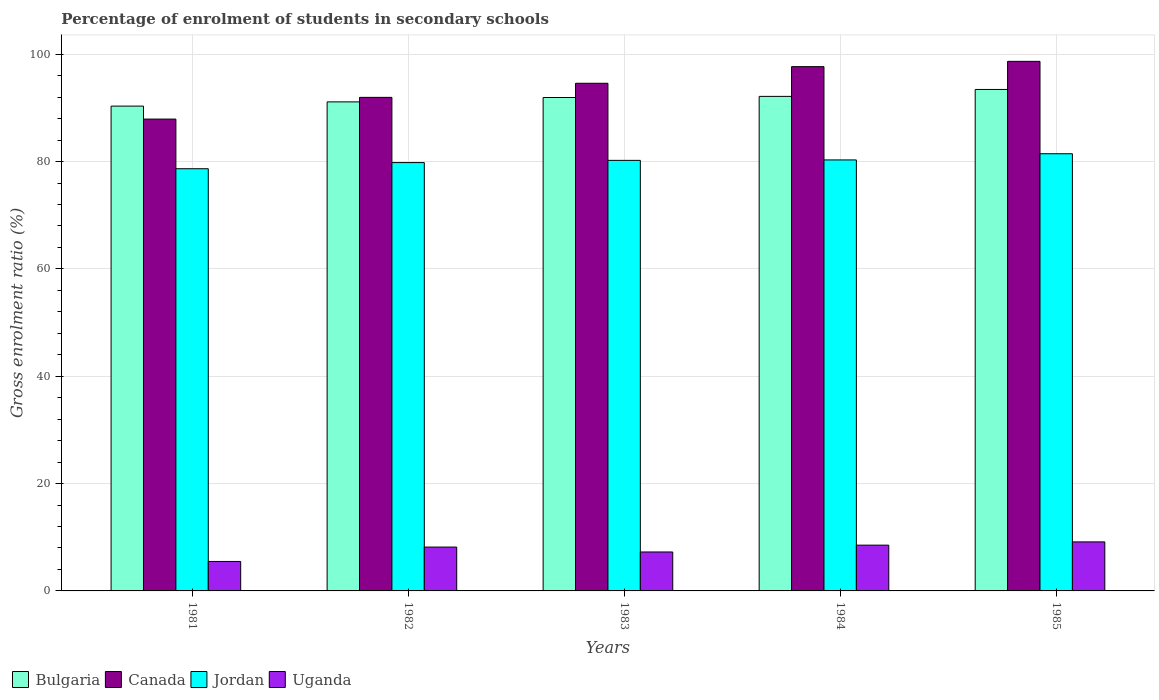How many different coloured bars are there?
Give a very brief answer. 4. How many groups of bars are there?
Make the answer very short. 5. Are the number of bars per tick equal to the number of legend labels?
Provide a succinct answer. Yes. How many bars are there on the 5th tick from the left?
Your answer should be very brief. 4. In how many cases, is the number of bars for a given year not equal to the number of legend labels?
Make the answer very short. 0. What is the percentage of students enrolled in secondary schools in Canada in 1983?
Your answer should be very brief. 94.59. Across all years, what is the maximum percentage of students enrolled in secondary schools in Jordan?
Offer a terse response. 81.46. Across all years, what is the minimum percentage of students enrolled in secondary schools in Bulgaria?
Ensure brevity in your answer.  90.34. What is the total percentage of students enrolled in secondary schools in Jordan in the graph?
Offer a terse response. 400.48. What is the difference between the percentage of students enrolled in secondary schools in Canada in 1981 and that in 1983?
Your answer should be very brief. -6.67. What is the difference between the percentage of students enrolled in secondary schools in Uganda in 1983 and the percentage of students enrolled in secondary schools in Bulgaria in 1984?
Make the answer very short. -84.89. What is the average percentage of students enrolled in secondary schools in Jordan per year?
Your response must be concise. 80.1. In the year 1985, what is the difference between the percentage of students enrolled in secondary schools in Jordan and percentage of students enrolled in secondary schools in Canada?
Your response must be concise. -17.21. In how many years, is the percentage of students enrolled in secondary schools in Bulgaria greater than 80 %?
Provide a succinct answer. 5. What is the ratio of the percentage of students enrolled in secondary schools in Jordan in 1981 to that in 1985?
Offer a very short reply. 0.97. Is the difference between the percentage of students enrolled in secondary schools in Jordan in 1981 and 1982 greater than the difference between the percentage of students enrolled in secondary schools in Canada in 1981 and 1982?
Make the answer very short. Yes. What is the difference between the highest and the second highest percentage of students enrolled in secondary schools in Uganda?
Give a very brief answer. 0.61. What is the difference between the highest and the lowest percentage of students enrolled in secondary schools in Jordan?
Keep it short and to the point. 2.79. Is the sum of the percentage of students enrolled in secondary schools in Jordan in 1981 and 1984 greater than the maximum percentage of students enrolled in secondary schools in Canada across all years?
Offer a terse response. Yes. What does the 4th bar from the left in 1984 represents?
Give a very brief answer. Uganda. What does the 1st bar from the right in 1983 represents?
Offer a very short reply. Uganda. Is it the case that in every year, the sum of the percentage of students enrolled in secondary schools in Bulgaria and percentage of students enrolled in secondary schools in Uganda is greater than the percentage of students enrolled in secondary schools in Canada?
Offer a very short reply. Yes. How many bars are there?
Offer a very short reply. 20. Are all the bars in the graph horizontal?
Your answer should be very brief. No. How many years are there in the graph?
Ensure brevity in your answer.  5. Does the graph contain any zero values?
Your answer should be compact. No. Does the graph contain grids?
Your answer should be very brief. Yes. How many legend labels are there?
Ensure brevity in your answer.  4. What is the title of the graph?
Keep it short and to the point. Percentage of enrolment of students in secondary schools. What is the label or title of the Y-axis?
Provide a succinct answer. Gross enrolment ratio (%). What is the Gross enrolment ratio (%) of Bulgaria in 1981?
Your response must be concise. 90.34. What is the Gross enrolment ratio (%) in Canada in 1981?
Keep it short and to the point. 87.92. What is the Gross enrolment ratio (%) of Jordan in 1981?
Your answer should be very brief. 78.67. What is the Gross enrolment ratio (%) in Uganda in 1981?
Keep it short and to the point. 5.49. What is the Gross enrolment ratio (%) in Bulgaria in 1982?
Provide a short and direct response. 91.13. What is the Gross enrolment ratio (%) of Canada in 1982?
Offer a very short reply. 91.96. What is the Gross enrolment ratio (%) of Jordan in 1982?
Offer a very short reply. 79.81. What is the Gross enrolment ratio (%) in Uganda in 1982?
Give a very brief answer. 8.17. What is the Gross enrolment ratio (%) of Bulgaria in 1983?
Your answer should be very brief. 91.94. What is the Gross enrolment ratio (%) in Canada in 1983?
Offer a very short reply. 94.59. What is the Gross enrolment ratio (%) in Jordan in 1983?
Provide a short and direct response. 80.23. What is the Gross enrolment ratio (%) of Uganda in 1983?
Provide a short and direct response. 7.26. What is the Gross enrolment ratio (%) of Bulgaria in 1984?
Ensure brevity in your answer.  92.15. What is the Gross enrolment ratio (%) of Canada in 1984?
Ensure brevity in your answer.  97.69. What is the Gross enrolment ratio (%) of Jordan in 1984?
Your answer should be very brief. 80.31. What is the Gross enrolment ratio (%) in Uganda in 1984?
Your response must be concise. 8.53. What is the Gross enrolment ratio (%) in Bulgaria in 1985?
Provide a short and direct response. 93.44. What is the Gross enrolment ratio (%) of Canada in 1985?
Provide a succinct answer. 98.68. What is the Gross enrolment ratio (%) in Jordan in 1985?
Make the answer very short. 81.46. What is the Gross enrolment ratio (%) of Uganda in 1985?
Provide a succinct answer. 9.13. Across all years, what is the maximum Gross enrolment ratio (%) of Bulgaria?
Make the answer very short. 93.44. Across all years, what is the maximum Gross enrolment ratio (%) in Canada?
Your response must be concise. 98.68. Across all years, what is the maximum Gross enrolment ratio (%) of Jordan?
Ensure brevity in your answer.  81.46. Across all years, what is the maximum Gross enrolment ratio (%) of Uganda?
Keep it short and to the point. 9.13. Across all years, what is the minimum Gross enrolment ratio (%) of Bulgaria?
Your answer should be compact. 90.34. Across all years, what is the minimum Gross enrolment ratio (%) of Canada?
Offer a terse response. 87.92. Across all years, what is the minimum Gross enrolment ratio (%) of Jordan?
Keep it short and to the point. 78.67. Across all years, what is the minimum Gross enrolment ratio (%) in Uganda?
Provide a succinct answer. 5.49. What is the total Gross enrolment ratio (%) in Bulgaria in the graph?
Make the answer very short. 458.99. What is the total Gross enrolment ratio (%) in Canada in the graph?
Ensure brevity in your answer.  470.84. What is the total Gross enrolment ratio (%) in Jordan in the graph?
Keep it short and to the point. 400.48. What is the total Gross enrolment ratio (%) of Uganda in the graph?
Give a very brief answer. 38.58. What is the difference between the Gross enrolment ratio (%) in Bulgaria in 1981 and that in 1982?
Your answer should be very brief. -0.79. What is the difference between the Gross enrolment ratio (%) of Canada in 1981 and that in 1982?
Keep it short and to the point. -4.04. What is the difference between the Gross enrolment ratio (%) of Jordan in 1981 and that in 1982?
Make the answer very short. -1.14. What is the difference between the Gross enrolment ratio (%) in Uganda in 1981 and that in 1982?
Ensure brevity in your answer.  -2.68. What is the difference between the Gross enrolment ratio (%) in Bulgaria in 1981 and that in 1983?
Give a very brief answer. -1.6. What is the difference between the Gross enrolment ratio (%) in Canada in 1981 and that in 1983?
Keep it short and to the point. -6.67. What is the difference between the Gross enrolment ratio (%) in Jordan in 1981 and that in 1983?
Provide a succinct answer. -1.56. What is the difference between the Gross enrolment ratio (%) in Uganda in 1981 and that in 1983?
Make the answer very short. -1.77. What is the difference between the Gross enrolment ratio (%) in Bulgaria in 1981 and that in 1984?
Your answer should be compact. -1.81. What is the difference between the Gross enrolment ratio (%) in Canada in 1981 and that in 1984?
Offer a very short reply. -9.77. What is the difference between the Gross enrolment ratio (%) in Jordan in 1981 and that in 1984?
Provide a short and direct response. -1.64. What is the difference between the Gross enrolment ratio (%) of Uganda in 1981 and that in 1984?
Provide a succinct answer. -3.04. What is the difference between the Gross enrolment ratio (%) in Bulgaria in 1981 and that in 1985?
Offer a very short reply. -3.1. What is the difference between the Gross enrolment ratio (%) in Canada in 1981 and that in 1985?
Make the answer very short. -10.76. What is the difference between the Gross enrolment ratio (%) of Jordan in 1981 and that in 1985?
Offer a very short reply. -2.79. What is the difference between the Gross enrolment ratio (%) in Uganda in 1981 and that in 1985?
Make the answer very short. -3.64. What is the difference between the Gross enrolment ratio (%) of Bulgaria in 1982 and that in 1983?
Your answer should be very brief. -0.82. What is the difference between the Gross enrolment ratio (%) of Canada in 1982 and that in 1983?
Provide a short and direct response. -2.63. What is the difference between the Gross enrolment ratio (%) in Jordan in 1982 and that in 1983?
Your answer should be very brief. -0.41. What is the difference between the Gross enrolment ratio (%) in Uganda in 1982 and that in 1983?
Provide a short and direct response. 0.91. What is the difference between the Gross enrolment ratio (%) of Bulgaria in 1982 and that in 1984?
Keep it short and to the point. -1.02. What is the difference between the Gross enrolment ratio (%) in Canada in 1982 and that in 1984?
Offer a very short reply. -5.73. What is the difference between the Gross enrolment ratio (%) of Jordan in 1982 and that in 1984?
Your response must be concise. -0.5. What is the difference between the Gross enrolment ratio (%) of Uganda in 1982 and that in 1984?
Give a very brief answer. -0.36. What is the difference between the Gross enrolment ratio (%) of Bulgaria in 1982 and that in 1985?
Offer a very short reply. -2.31. What is the difference between the Gross enrolment ratio (%) in Canada in 1982 and that in 1985?
Offer a terse response. -6.71. What is the difference between the Gross enrolment ratio (%) of Jordan in 1982 and that in 1985?
Offer a terse response. -1.65. What is the difference between the Gross enrolment ratio (%) of Uganda in 1982 and that in 1985?
Provide a short and direct response. -0.96. What is the difference between the Gross enrolment ratio (%) in Bulgaria in 1983 and that in 1984?
Provide a short and direct response. -0.21. What is the difference between the Gross enrolment ratio (%) of Canada in 1983 and that in 1984?
Keep it short and to the point. -3.1. What is the difference between the Gross enrolment ratio (%) in Jordan in 1983 and that in 1984?
Offer a terse response. -0.08. What is the difference between the Gross enrolment ratio (%) in Uganda in 1983 and that in 1984?
Provide a succinct answer. -1.27. What is the difference between the Gross enrolment ratio (%) of Bulgaria in 1983 and that in 1985?
Your answer should be very brief. -1.5. What is the difference between the Gross enrolment ratio (%) of Canada in 1983 and that in 1985?
Ensure brevity in your answer.  -4.09. What is the difference between the Gross enrolment ratio (%) in Jordan in 1983 and that in 1985?
Make the answer very short. -1.24. What is the difference between the Gross enrolment ratio (%) in Uganda in 1983 and that in 1985?
Make the answer very short. -1.88. What is the difference between the Gross enrolment ratio (%) of Bulgaria in 1984 and that in 1985?
Give a very brief answer. -1.29. What is the difference between the Gross enrolment ratio (%) of Canada in 1984 and that in 1985?
Provide a succinct answer. -0.99. What is the difference between the Gross enrolment ratio (%) of Jordan in 1984 and that in 1985?
Provide a short and direct response. -1.15. What is the difference between the Gross enrolment ratio (%) in Uganda in 1984 and that in 1985?
Ensure brevity in your answer.  -0.61. What is the difference between the Gross enrolment ratio (%) of Bulgaria in 1981 and the Gross enrolment ratio (%) of Canada in 1982?
Keep it short and to the point. -1.63. What is the difference between the Gross enrolment ratio (%) of Bulgaria in 1981 and the Gross enrolment ratio (%) of Jordan in 1982?
Your response must be concise. 10.53. What is the difference between the Gross enrolment ratio (%) in Bulgaria in 1981 and the Gross enrolment ratio (%) in Uganda in 1982?
Offer a very short reply. 82.17. What is the difference between the Gross enrolment ratio (%) in Canada in 1981 and the Gross enrolment ratio (%) in Jordan in 1982?
Make the answer very short. 8.11. What is the difference between the Gross enrolment ratio (%) of Canada in 1981 and the Gross enrolment ratio (%) of Uganda in 1982?
Ensure brevity in your answer.  79.75. What is the difference between the Gross enrolment ratio (%) in Jordan in 1981 and the Gross enrolment ratio (%) in Uganda in 1982?
Your answer should be compact. 70.5. What is the difference between the Gross enrolment ratio (%) of Bulgaria in 1981 and the Gross enrolment ratio (%) of Canada in 1983?
Your response must be concise. -4.25. What is the difference between the Gross enrolment ratio (%) of Bulgaria in 1981 and the Gross enrolment ratio (%) of Jordan in 1983?
Your response must be concise. 10.11. What is the difference between the Gross enrolment ratio (%) in Bulgaria in 1981 and the Gross enrolment ratio (%) in Uganda in 1983?
Offer a very short reply. 83.08. What is the difference between the Gross enrolment ratio (%) of Canada in 1981 and the Gross enrolment ratio (%) of Jordan in 1983?
Offer a very short reply. 7.69. What is the difference between the Gross enrolment ratio (%) of Canada in 1981 and the Gross enrolment ratio (%) of Uganda in 1983?
Offer a terse response. 80.66. What is the difference between the Gross enrolment ratio (%) of Jordan in 1981 and the Gross enrolment ratio (%) of Uganda in 1983?
Your answer should be compact. 71.41. What is the difference between the Gross enrolment ratio (%) in Bulgaria in 1981 and the Gross enrolment ratio (%) in Canada in 1984?
Give a very brief answer. -7.35. What is the difference between the Gross enrolment ratio (%) of Bulgaria in 1981 and the Gross enrolment ratio (%) of Jordan in 1984?
Keep it short and to the point. 10.03. What is the difference between the Gross enrolment ratio (%) in Bulgaria in 1981 and the Gross enrolment ratio (%) in Uganda in 1984?
Offer a terse response. 81.81. What is the difference between the Gross enrolment ratio (%) of Canada in 1981 and the Gross enrolment ratio (%) of Jordan in 1984?
Your answer should be compact. 7.61. What is the difference between the Gross enrolment ratio (%) in Canada in 1981 and the Gross enrolment ratio (%) in Uganda in 1984?
Provide a succinct answer. 79.39. What is the difference between the Gross enrolment ratio (%) in Jordan in 1981 and the Gross enrolment ratio (%) in Uganda in 1984?
Provide a short and direct response. 70.14. What is the difference between the Gross enrolment ratio (%) in Bulgaria in 1981 and the Gross enrolment ratio (%) in Canada in 1985?
Offer a very short reply. -8.34. What is the difference between the Gross enrolment ratio (%) of Bulgaria in 1981 and the Gross enrolment ratio (%) of Jordan in 1985?
Ensure brevity in your answer.  8.87. What is the difference between the Gross enrolment ratio (%) in Bulgaria in 1981 and the Gross enrolment ratio (%) in Uganda in 1985?
Provide a short and direct response. 81.2. What is the difference between the Gross enrolment ratio (%) of Canada in 1981 and the Gross enrolment ratio (%) of Jordan in 1985?
Provide a short and direct response. 6.46. What is the difference between the Gross enrolment ratio (%) of Canada in 1981 and the Gross enrolment ratio (%) of Uganda in 1985?
Your answer should be very brief. 78.79. What is the difference between the Gross enrolment ratio (%) in Jordan in 1981 and the Gross enrolment ratio (%) in Uganda in 1985?
Keep it short and to the point. 69.53. What is the difference between the Gross enrolment ratio (%) of Bulgaria in 1982 and the Gross enrolment ratio (%) of Canada in 1983?
Give a very brief answer. -3.47. What is the difference between the Gross enrolment ratio (%) of Bulgaria in 1982 and the Gross enrolment ratio (%) of Jordan in 1983?
Offer a terse response. 10.9. What is the difference between the Gross enrolment ratio (%) of Bulgaria in 1982 and the Gross enrolment ratio (%) of Uganda in 1983?
Your answer should be very brief. 83.87. What is the difference between the Gross enrolment ratio (%) in Canada in 1982 and the Gross enrolment ratio (%) in Jordan in 1983?
Your response must be concise. 11.74. What is the difference between the Gross enrolment ratio (%) of Canada in 1982 and the Gross enrolment ratio (%) of Uganda in 1983?
Provide a succinct answer. 84.71. What is the difference between the Gross enrolment ratio (%) in Jordan in 1982 and the Gross enrolment ratio (%) in Uganda in 1983?
Ensure brevity in your answer.  72.55. What is the difference between the Gross enrolment ratio (%) in Bulgaria in 1982 and the Gross enrolment ratio (%) in Canada in 1984?
Keep it short and to the point. -6.56. What is the difference between the Gross enrolment ratio (%) in Bulgaria in 1982 and the Gross enrolment ratio (%) in Jordan in 1984?
Your answer should be compact. 10.82. What is the difference between the Gross enrolment ratio (%) in Bulgaria in 1982 and the Gross enrolment ratio (%) in Uganda in 1984?
Your response must be concise. 82.6. What is the difference between the Gross enrolment ratio (%) in Canada in 1982 and the Gross enrolment ratio (%) in Jordan in 1984?
Your answer should be very brief. 11.66. What is the difference between the Gross enrolment ratio (%) in Canada in 1982 and the Gross enrolment ratio (%) in Uganda in 1984?
Make the answer very short. 83.44. What is the difference between the Gross enrolment ratio (%) in Jordan in 1982 and the Gross enrolment ratio (%) in Uganda in 1984?
Make the answer very short. 71.28. What is the difference between the Gross enrolment ratio (%) of Bulgaria in 1982 and the Gross enrolment ratio (%) of Canada in 1985?
Ensure brevity in your answer.  -7.55. What is the difference between the Gross enrolment ratio (%) in Bulgaria in 1982 and the Gross enrolment ratio (%) in Jordan in 1985?
Offer a very short reply. 9.66. What is the difference between the Gross enrolment ratio (%) in Bulgaria in 1982 and the Gross enrolment ratio (%) in Uganda in 1985?
Make the answer very short. 81.99. What is the difference between the Gross enrolment ratio (%) in Canada in 1982 and the Gross enrolment ratio (%) in Jordan in 1985?
Ensure brevity in your answer.  10.5. What is the difference between the Gross enrolment ratio (%) of Canada in 1982 and the Gross enrolment ratio (%) of Uganda in 1985?
Provide a short and direct response. 82.83. What is the difference between the Gross enrolment ratio (%) of Jordan in 1982 and the Gross enrolment ratio (%) of Uganda in 1985?
Provide a succinct answer. 70.68. What is the difference between the Gross enrolment ratio (%) of Bulgaria in 1983 and the Gross enrolment ratio (%) of Canada in 1984?
Offer a very short reply. -5.75. What is the difference between the Gross enrolment ratio (%) in Bulgaria in 1983 and the Gross enrolment ratio (%) in Jordan in 1984?
Your answer should be compact. 11.63. What is the difference between the Gross enrolment ratio (%) in Bulgaria in 1983 and the Gross enrolment ratio (%) in Uganda in 1984?
Ensure brevity in your answer.  83.41. What is the difference between the Gross enrolment ratio (%) of Canada in 1983 and the Gross enrolment ratio (%) of Jordan in 1984?
Provide a succinct answer. 14.28. What is the difference between the Gross enrolment ratio (%) of Canada in 1983 and the Gross enrolment ratio (%) of Uganda in 1984?
Make the answer very short. 86.06. What is the difference between the Gross enrolment ratio (%) of Jordan in 1983 and the Gross enrolment ratio (%) of Uganda in 1984?
Keep it short and to the point. 71.7. What is the difference between the Gross enrolment ratio (%) in Bulgaria in 1983 and the Gross enrolment ratio (%) in Canada in 1985?
Offer a terse response. -6.74. What is the difference between the Gross enrolment ratio (%) of Bulgaria in 1983 and the Gross enrolment ratio (%) of Jordan in 1985?
Your answer should be compact. 10.48. What is the difference between the Gross enrolment ratio (%) in Bulgaria in 1983 and the Gross enrolment ratio (%) in Uganda in 1985?
Offer a very short reply. 82.81. What is the difference between the Gross enrolment ratio (%) of Canada in 1983 and the Gross enrolment ratio (%) of Jordan in 1985?
Your response must be concise. 13.13. What is the difference between the Gross enrolment ratio (%) of Canada in 1983 and the Gross enrolment ratio (%) of Uganda in 1985?
Offer a very short reply. 85.46. What is the difference between the Gross enrolment ratio (%) of Jordan in 1983 and the Gross enrolment ratio (%) of Uganda in 1985?
Your response must be concise. 71.09. What is the difference between the Gross enrolment ratio (%) of Bulgaria in 1984 and the Gross enrolment ratio (%) of Canada in 1985?
Ensure brevity in your answer.  -6.53. What is the difference between the Gross enrolment ratio (%) in Bulgaria in 1984 and the Gross enrolment ratio (%) in Jordan in 1985?
Ensure brevity in your answer.  10.69. What is the difference between the Gross enrolment ratio (%) of Bulgaria in 1984 and the Gross enrolment ratio (%) of Uganda in 1985?
Give a very brief answer. 83.01. What is the difference between the Gross enrolment ratio (%) in Canada in 1984 and the Gross enrolment ratio (%) in Jordan in 1985?
Keep it short and to the point. 16.23. What is the difference between the Gross enrolment ratio (%) of Canada in 1984 and the Gross enrolment ratio (%) of Uganda in 1985?
Make the answer very short. 88.56. What is the difference between the Gross enrolment ratio (%) in Jordan in 1984 and the Gross enrolment ratio (%) in Uganda in 1985?
Keep it short and to the point. 71.17. What is the average Gross enrolment ratio (%) in Bulgaria per year?
Provide a succinct answer. 91.8. What is the average Gross enrolment ratio (%) of Canada per year?
Ensure brevity in your answer.  94.17. What is the average Gross enrolment ratio (%) in Jordan per year?
Offer a very short reply. 80.1. What is the average Gross enrolment ratio (%) of Uganda per year?
Ensure brevity in your answer.  7.72. In the year 1981, what is the difference between the Gross enrolment ratio (%) in Bulgaria and Gross enrolment ratio (%) in Canada?
Keep it short and to the point. 2.42. In the year 1981, what is the difference between the Gross enrolment ratio (%) of Bulgaria and Gross enrolment ratio (%) of Jordan?
Offer a terse response. 11.67. In the year 1981, what is the difference between the Gross enrolment ratio (%) of Bulgaria and Gross enrolment ratio (%) of Uganda?
Offer a very short reply. 84.85. In the year 1981, what is the difference between the Gross enrolment ratio (%) of Canada and Gross enrolment ratio (%) of Jordan?
Provide a succinct answer. 9.25. In the year 1981, what is the difference between the Gross enrolment ratio (%) of Canada and Gross enrolment ratio (%) of Uganda?
Your answer should be compact. 82.43. In the year 1981, what is the difference between the Gross enrolment ratio (%) of Jordan and Gross enrolment ratio (%) of Uganda?
Provide a succinct answer. 73.18. In the year 1982, what is the difference between the Gross enrolment ratio (%) in Bulgaria and Gross enrolment ratio (%) in Canada?
Your answer should be compact. -0.84. In the year 1982, what is the difference between the Gross enrolment ratio (%) in Bulgaria and Gross enrolment ratio (%) in Jordan?
Provide a short and direct response. 11.31. In the year 1982, what is the difference between the Gross enrolment ratio (%) of Bulgaria and Gross enrolment ratio (%) of Uganda?
Give a very brief answer. 82.95. In the year 1982, what is the difference between the Gross enrolment ratio (%) of Canada and Gross enrolment ratio (%) of Jordan?
Keep it short and to the point. 12.15. In the year 1982, what is the difference between the Gross enrolment ratio (%) of Canada and Gross enrolment ratio (%) of Uganda?
Provide a short and direct response. 83.79. In the year 1982, what is the difference between the Gross enrolment ratio (%) in Jordan and Gross enrolment ratio (%) in Uganda?
Your answer should be compact. 71.64. In the year 1983, what is the difference between the Gross enrolment ratio (%) in Bulgaria and Gross enrolment ratio (%) in Canada?
Your response must be concise. -2.65. In the year 1983, what is the difference between the Gross enrolment ratio (%) in Bulgaria and Gross enrolment ratio (%) in Jordan?
Offer a very short reply. 11.72. In the year 1983, what is the difference between the Gross enrolment ratio (%) in Bulgaria and Gross enrolment ratio (%) in Uganda?
Offer a very short reply. 84.68. In the year 1983, what is the difference between the Gross enrolment ratio (%) of Canada and Gross enrolment ratio (%) of Jordan?
Your answer should be compact. 14.37. In the year 1983, what is the difference between the Gross enrolment ratio (%) in Canada and Gross enrolment ratio (%) in Uganda?
Offer a very short reply. 87.33. In the year 1983, what is the difference between the Gross enrolment ratio (%) in Jordan and Gross enrolment ratio (%) in Uganda?
Offer a terse response. 72.97. In the year 1984, what is the difference between the Gross enrolment ratio (%) in Bulgaria and Gross enrolment ratio (%) in Canada?
Your response must be concise. -5.54. In the year 1984, what is the difference between the Gross enrolment ratio (%) of Bulgaria and Gross enrolment ratio (%) of Jordan?
Your answer should be compact. 11.84. In the year 1984, what is the difference between the Gross enrolment ratio (%) in Bulgaria and Gross enrolment ratio (%) in Uganda?
Your answer should be very brief. 83.62. In the year 1984, what is the difference between the Gross enrolment ratio (%) in Canada and Gross enrolment ratio (%) in Jordan?
Offer a terse response. 17.38. In the year 1984, what is the difference between the Gross enrolment ratio (%) in Canada and Gross enrolment ratio (%) in Uganda?
Your answer should be very brief. 89.16. In the year 1984, what is the difference between the Gross enrolment ratio (%) of Jordan and Gross enrolment ratio (%) of Uganda?
Provide a short and direct response. 71.78. In the year 1985, what is the difference between the Gross enrolment ratio (%) of Bulgaria and Gross enrolment ratio (%) of Canada?
Offer a terse response. -5.24. In the year 1985, what is the difference between the Gross enrolment ratio (%) of Bulgaria and Gross enrolment ratio (%) of Jordan?
Keep it short and to the point. 11.98. In the year 1985, what is the difference between the Gross enrolment ratio (%) of Bulgaria and Gross enrolment ratio (%) of Uganda?
Your response must be concise. 84.3. In the year 1985, what is the difference between the Gross enrolment ratio (%) in Canada and Gross enrolment ratio (%) in Jordan?
Keep it short and to the point. 17.21. In the year 1985, what is the difference between the Gross enrolment ratio (%) of Canada and Gross enrolment ratio (%) of Uganda?
Your answer should be very brief. 89.54. In the year 1985, what is the difference between the Gross enrolment ratio (%) of Jordan and Gross enrolment ratio (%) of Uganda?
Ensure brevity in your answer.  72.33. What is the ratio of the Gross enrolment ratio (%) in Bulgaria in 1981 to that in 1982?
Offer a very short reply. 0.99. What is the ratio of the Gross enrolment ratio (%) in Canada in 1981 to that in 1982?
Provide a succinct answer. 0.96. What is the ratio of the Gross enrolment ratio (%) of Jordan in 1981 to that in 1982?
Provide a short and direct response. 0.99. What is the ratio of the Gross enrolment ratio (%) in Uganda in 1981 to that in 1982?
Keep it short and to the point. 0.67. What is the ratio of the Gross enrolment ratio (%) of Bulgaria in 1981 to that in 1983?
Make the answer very short. 0.98. What is the ratio of the Gross enrolment ratio (%) of Canada in 1981 to that in 1983?
Offer a very short reply. 0.93. What is the ratio of the Gross enrolment ratio (%) in Jordan in 1981 to that in 1983?
Your answer should be compact. 0.98. What is the ratio of the Gross enrolment ratio (%) in Uganda in 1981 to that in 1983?
Provide a succinct answer. 0.76. What is the ratio of the Gross enrolment ratio (%) in Bulgaria in 1981 to that in 1984?
Your response must be concise. 0.98. What is the ratio of the Gross enrolment ratio (%) of Jordan in 1981 to that in 1984?
Keep it short and to the point. 0.98. What is the ratio of the Gross enrolment ratio (%) of Uganda in 1981 to that in 1984?
Ensure brevity in your answer.  0.64. What is the ratio of the Gross enrolment ratio (%) of Bulgaria in 1981 to that in 1985?
Make the answer very short. 0.97. What is the ratio of the Gross enrolment ratio (%) of Canada in 1981 to that in 1985?
Keep it short and to the point. 0.89. What is the ratio of the Gross enrolment ratio (%) of Jordan in 1981 to that in 1985?
Offer a terse response. 0.97. What is the ratio of the Gross enrolment ratio (%) of Uganda in 1981 to that in 1985?
Give a very brief answer. 0.6. What is the ratio of the Gross enrolment ratio (%) in Canada in 1982 to that in 1983?
Provide a succinct answer. 0.97. What is the ratio of the Gross enrolment ratio (%) in Uganda in 1982 to that in 1983?
Your answer should be compact. 1.13. What is the ratio of the Gross enrolment ratio (%) of Bulgaria in 1982 to that in 1984?
Offer a very short reply. 0.99. What is the ratio of the Gross enrolment ratio (%) in Canada in 1982 to that in 1984?
Make the answer very short. 0.94. What is the ratio of the Gross enrolment ratio (%) in Uganda in 1982 to that in 1984?
Offer a terse response. 0.96. What is the ratio of the Gross enrolment ratio (%) of Bulgaria in 1982 to that in 1985?
Offer a very short reply. 0.98. What is the ratio of the Gross enrolment ratio (%) of Canada in 1982 to that in 1985?
Your answer should be compact. 0.93. What is the ratio of the Gross enrolment ratio (%) in Jordan in 1982 to that in 1985?
Your answer should be very brief. 0.98. What is the ratio of the Gross enrolment ratio (%) of Uganda in 1982 to that in 1985?
Ensure brevity in your answer.  0.89. What is the ratio of the Gross enrolment ratio (%) of Bulgaria in 1983 to that in 1984?
Ensure brevity in your answer.  1. What is the ratio of the Gross enrolment ratio (%) of Canada in 1983 to that in 1984?
Your response must be concise. 0.97. What is the ratio of the Gross enrolment ratio (%) in Jordan in 1983 to that in 1984?
Ensure brevity in your answer.  1. What is the ratio of the Gross enrolment ratio (%) in Uganda in 1983 to that in 1984?
Your answer should be compact. 0.85. What is the ratio of the Gross enrolment ratio (%) of Canada in 1983 to that in 1985?
Provide a succinct answer. 0.96. What is the ratio of the Gross enrolment ratio (%) of Jordan in 1983 to that in 1985?
Keep it short and to the point. 0.98. What is the ratio of the Gross enrolment ratio (%) of Uganda in 1983 to that in 1985?
Offer a terse response. 0.79. What is the ratio of the Gross enrolment ratio (%) in Bulgaria in 1984 to that in 1985?
Keep it short and to the point. 0.99. What is the ratio of the Gross enrolment ratio (%) in Jordan in 1984 to that in 1985?
Give a very brief answer. 0.99. What is the ratio of the Gross enrolment ratio (%) of Uganda in 1984 to that in 1985?
Give a very brief answer. 0.93. What is the difference between the highest and the second highest Gross enrolment ratio (%) in Bulgaria?
Offer a very short reply. 1.29. What is the difference between the highest and the second highest Gross enrolment ratio (%) of Canada?
Offer a very short reply. 0.99. What is the difference between the highest and the second highest Gross enrolment ratio (%) of Jordan?
Offer a terse response. 1.15. What is the difference between the highest and the second highest Gross enrolment ratio (%) of Uganda?
Your answer should be very brief. 0.61. What is the difference between the highest and the lowest Gross enrolment ratio (%) in Bulgaria?
Your answer should be compact. 3.1. What is the difference between the highest and the lowest Gross enrolment ratio (%) in Canada?
Provide a succinct answer. 10.76. What is the difference between the highest and the lowest Gross enrolment ratio (%) in Jordan?
Your response must be concise. 2.79. What is the difference between the highest and the lowest Gross enrolment ratio (%) of Uganda?
Offer a terse response. 3.64. 